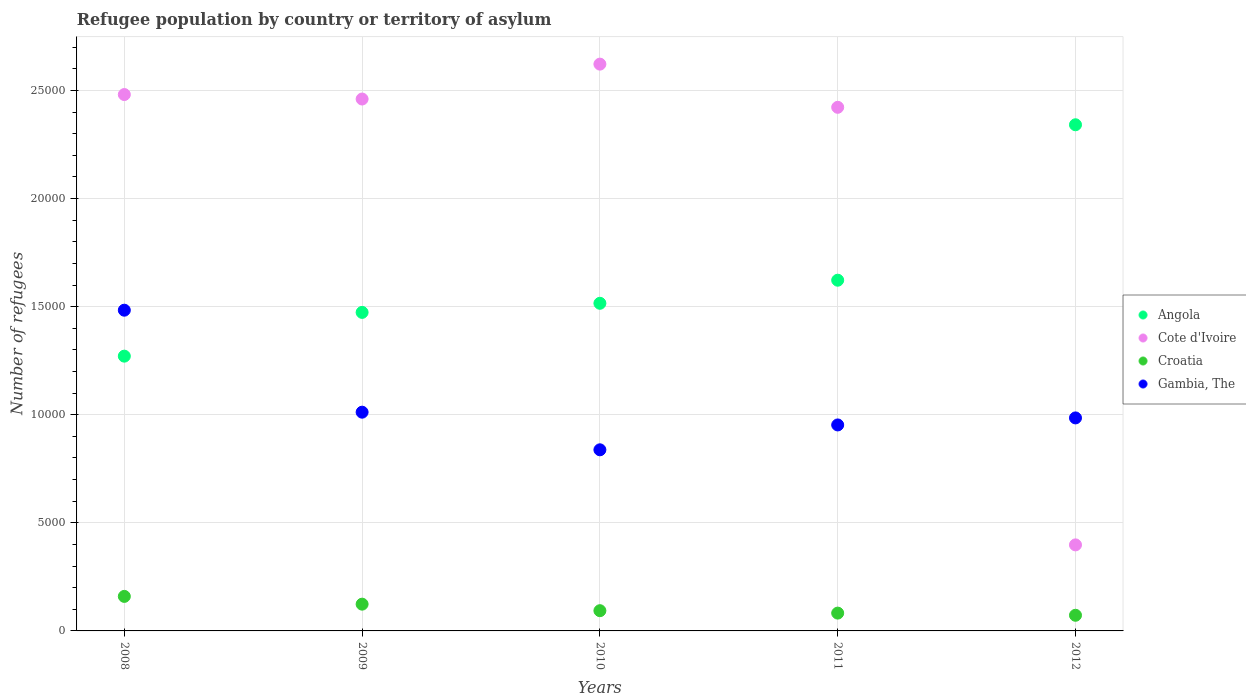What is the number of refugees in Cote d'Ivoire in 2011?
Offer a very short reply. 2.42e+04. Across all years, what is the maximum number of refugees in Angola?
Give a very brief answer. 2.34e+04. Across all years, what is the minimum number of refugees in Angola?
Offer a terse response. 1.27e+04. In which year was the number of refugees in Cote d'Ivoire maximum?
Your answer should be compact. 2010. In which year was the number of refugees in Gambia, The minimum?
Ensure brevity in your answer.  2010. What is the total number of refugees in Croatia in the graph?
Make the answer very short. 5319. What is the difference between the number of refugees in Angola in 2008 and that in 2012?
Your answer should be very brief. -1.07e+04. What is the difference between the number of refugees in Angola in 2011 and the number of refugees in Cote d'Ivoire in 2012?
Keep it short and to the point. 1.22e+04. What is the average number of refugees in Angola per year?
Your response must be concise. 1.64e+04. In the year 2012, what is the difference between the number of refugees in Croatia and number of refugees in Angola?
Keep it short and to the point. -2.27e+04. What is the ratio of the number of refugees in Cote d'Ivoire in 2010 to that in 2012?
Make the answer very short. 6.59. What is the difference between the highest and the second highest number of refugees in Gambia, The?
Your answer should be compact. 4718. What is the difference between the highest and the lowest number of refugees in Cote d'Ivoire?
Make the answer very short. 2.22e+04. Is the sum of the number of refugees in Angola in 2009 and 2010 greater than the maximum number of refugees in Croatia across all years?
Ensure brevity in your answer.  Yes. Is it the case that in every year, the sum of the number of refugees in Angola and number of refugees in Gambia, The  is greater than the sum of number of refugees in Cote d'Ivoire and number of refugees in Croatia?
Give a very brief answer. No. How many dotlines are there?
Offer a terse response. 4. What is the difference between two consecutive major ticks on the Y-axis?
Your response must be concise. 5000. Are the values on the major ticks of Y-axis written in scientific E-notation?
Provide a short and direct response. No. Does the graph contain grids?
Make the answer very short. Yes. How many legend labels are there?
Ensure brevity in your answer.  4. How are the legend labels stacked?
Your answer should be very brief. Vertical. What is the title of the graph?
Ensure brevity in your answer.  Refugee population by country or territory of asylum. What is the label or title of the Y-axis?
Make the answer very short. Number of refugees. What is the Number of refugees of Angola in 2008?
Your answer should be very brief. 1.27e+04. What is the Number of refugees in Cote d'Ivoire in 2008?
Give a very brief answer. 2.48e+04. What is the Number of refugees of Croatia in 2008?
Provide a short and direct response. 1597. What is the Number of refugees of Gambia, The in 2008?
Ensure brevity in your answer.  1.48e+04. What is the Number of refugees in Angola in 2009?
Provide a short and direct response. 1.47e+04. What is the Number of refugees of Cote d'Ivoire in 2009?
Provide a short and direct response. 2.46e+04. What is the Number of refugees in Croatia in 2009?
Your answer should be compact. 1238. What is the Number of refugees in Gambia, The in 2009?
Keep it short and to the point. 1.01e+04. What is the Number of refugees of Angola in 2010?
Keep it short and to the point. 1.52e+04. What is the Number of refugees of Cote d'Ivoire in 2010?
Offer a terse response. 2.62e+04. What is the Number of refugees in Croatia in 2010?
Ensure brevity in your answer.  936. What is the Number of refugees of Gambia, The in 2010?
Offer a terse response. 8378. What is the Number of refugees in Angola in 2011?
Give a very brief answer. 1.62e+04. What is the Number of refugees of Cote d'Ivoire in 2011?
Your response must be concise. 2.42e+04. What is the Number of refugees of Croatia in 2011?
Ensure brevity in your answer.  824. What is the Number of refugees in Gambia, The in 2011?
Ensure brevity in your answer.  9528. What is the Number of refugees in Angola in 2012?
Provide a short and direct response. 2.34e+04. What is the Number of refugees of Cote d'Ivoire in 2012?
Provide a short and direct response. 3980. What is the Number of refugees of Croatia in 2012?
Ensure brevity in your answer.  724. What is the Number of refugees of Gambia, The in 2012?
Provide a short and direct response. 9853. Across all years, what is the maximum Number of refugees of Angola?
Give a very brief answer. 2.34e+04. Across all years, what is the maximum Number of refugees of Cote d'Ivoire?
Provide a succinct answer. 2.62e+04. Across all years, what is the maximum Number of refugees in Croatia?
Provide a short and direct response. 1597. Across all years, what is the maximum Number of refugees in Gambia, The?
Provide a succinct answer. 1.48e+04. Across all years, what is the minimum Number of refugees in Angola?
Make the answer very short. 1.27e+04. Across all years, what is the minimum Number of refugees of Cote d'Ivoire?
Ensure brevity in your answer.  3980. Across all years, what is the minimum Number of refugees in Croatia?
Give a very brief answer. 724. Across all years, what is the minimum Number of refugees in Gambia, The?
Keep it short and to the point. 8378. What is the total Number of refugees in Angola in the graph?
Ensure brevity in your answer.  8.22e+04. What is the total Number of refugees of Cote d'Ivoire in the graph?
Offer a very short reply. 1.04e+05. What is the total Number of refugees in Croatia in the graph?
Keep it short and to the point. 5319. What is the total Number of refugees of Gambia, The in the graph?
Make the answer very short. 5.27e+04. What is the difference between the Number of refugees in Angola in 2008 and that in 2009?
Your answer should be very brief. -2024. What is the difference between the Number of refugees in Cote d'Ivoire in 2008 and that in 2009?
Provide a short and direct response. 207. What is the difference between the Number of refugees in Croatia in 2008 and that in 2009?
Your answer should be compact. 359. What is the difference between the Number of refugees of Gambia, The in 2008 and that in 2009?
Provide a short and direct response. 4718. What is the difference between the Number of refugees in Angola in 2008 and that in 2010?
Ensure brevity in your answer.  -2445. What is the difference between the Number of refugees of Cote d'Ivoire in 2008 and that in 2010?
Give a very brief answer. -1407. What is the difference between the Number of refugees of Croatia in 2008 and that in 2010?
Keep it short and to the point. 661. What is the difference between the Number of refugees in Gambia, The in 2008 and that in 2010?
Keep it short and to the point. 6458. What is the difference between the Number of refugees in Angola in 2008 and that in 2011?
Provide a short and direct response. -3513. What is the difference between the Number of refugees in Cote d'Ivoire in 2008 and that in 2011?
Offer a terse response. 590. What is the difference between the Number of refugees of Croatia in 2008 and that in 2011?
Make the answer very short. 773. What is the difference between the Number of refugees of Gambia, The in 2008 and that in 2011?
Offer a terse response. 5308. What is the difference between the Number of refugees in Angola in 2008 and that in 2012?
Keep it short and to the point. -1.07e+04. What is the difference between the Number of refugees in Cote d'Ivoire in 2008 and that in 2012?
Ensure brevity in your answer.  2.08e+04. What is the difference between the Number of refugees of Croatia in 2008 and that in 2012?
Your response must be concise. 873. What is the difference between the Number of refugees in Gambia, The in 2008 and that in 2012?
Your answer should be compact. 4983. What is the difference between the Number of refugees in Angola in 2009 and that in 2010?
Offer a very short reply. -421. What is the difference between the Number of refugees in Cote d'Ivoire in 2009 and that in 2010?
Make the answer very short. -1614. What is the difference between the Number of refugees in Croatia in 2009 and that in 2010?
Your answer should be compact. 302. What is the difference between the Number of refugees of Gambia, The in 2009 and that in 2010?
Give a very brief answer. 1740. What is the difference between the Number of refugees in Angola in 2009 and that in 2011?
Keep it short and to the point. -1489. What is the difference between the Number of refugees of Cote d'Ivoire in 2009 and that in 2011?
Make the answer very short. 383. What is the difference between the Number of refugees in Croatia in 2009 and that in 2011?
Provide a succinct answer. 414. What is the difference between the Number of refugees in Gambia, The in 2009 and that in 2011?
Your response must be concise. 590. What is the difference between the Number of refugees in Angola in 2009 and that in 2012?
Your response must be concise. -8679. What is the difference between the Number of refugees of Cote d'Ivoire in 2009 and that in 2012?
Your answer should be compact. 2.06e+04. What is the difference between the Number of refugees in Croatia in 2009 and that in 2012?
Provide a short and direct response. 514. What is the difference between the Number of refugees of Gambia, The in 2009 and that in 2012?
Your answer should be very brief. 265. What is the difference between the Number of refugees in Angola in 2010 and that in 2011?
Your answer should be compact. -1068. What is the difference between the Number of refugees in Cote d'Ivoire in 2010 and that in 2011?
Provide a succinct answer. 1997. What is the difference between the Number of refugees in Croatia in 2010 and that in 2011?
Provide a succinct answer. 112. What is the difference between the Number of refugees of Gambia, The in 2010 and that in 2011?
Your answer should be very brief. -1150. What is the difference between the Number of refugees of Angola in 2010 and that in 2012?
Provide a short and direct response. -8258. What is the difference between the Number of refugees of Cote d'Ivoire in 2010 and that in 2012?
Offer a very short reply. 2.22e+04. What is the difference between the Number of refugees in Croatia in 2010 and that in 2012?
Your answer should be compact. 212. What is the difference between the Number of refugees in Gambia, The in 2010 and that in 2012?
Give a very brief answer. -1475. What is the difference between the Number of refugees in Angola in 2011 and that in 2012?
Provide a succinct answer. -7190. What is the difference between the Number of refugees in Cote d'Ivoire in 2011 and that in 2012?
Provide a succinct answer. 2.02e+04. What is the difference between the Number of refugees in Croatia in 2011 and that in 2012?
Give a very brief answer. 100. What is the difference between the Number of refugees of Gambia, The in 2011 and that in 2012?
Offer a terse response. -325. What is the difference between the Number of refugees of Angola in 2008 and the Number of refugees of Cote d'Ivoire in 2009?
Provide a short and direct response. -1.19e+04. What is the difference between the Number of refugees in Angola in 2008 and the Number of refugees in Croatia in 2009?
Your answer should be compact. 1.15e+04. What is the difference between the Number of refugees in Angola in 2008 and the Number of refugees in Gambia, The in 2009?
Offer a terse response. 2592. What is the difference between the Number of refugees in Cote d'Ivoire in 2008 and the Number of refugees in Croatia in 2009?
Make the answer very short. 2.36e+04. What is the difference between the Number of refugees in Cote d'Ivoire in 2008 and the Number of refugees in Gambia, The in 2009?
Make the answer very short. 1.47e+04. What is the difference between the Number of refugees in Croatia in 2008 and the Number of refugees in Gambia, The in 2009?
Ensure brevity in your answer.  -8521. What is the difference between the Number of refugees of Angola in 2008 and the Number of refugees of Cote d'Ivoire in 2010?
Your answer should be compact. -1.35e+04. What is the difference between the Number of refugees in Angola in 2008 and the Number of refugees in Croatia in 2010?
Ensure brevity in your answer.  1.18e+04. What is the difference between the Number of refugees in Angola in 2008 and the Number of refugees in Gambia, The in 2010?
Ensure brevity in your answer.  4332. What is the difference between the Number of refugees in Cote d'Ivoire in 2008 and the Number of refugees in Croatia in 2010?
Offer a very short reply. 2.39e+04. What is the difference between the Number of refugees of Cote d'Ivoire in 2008 and the Number of refugees of Gambia, The in 2010?
Offer a very short reply. 1.64e+04. What is the difference between the Number of refugees of Croatia in 2008 and the Number of refugees of Gambia, The in 2010?
Offer a very short reply. -6781. What is the difference between the Number of refugees in Angola in 2008 and the Number of refugees in Cote d'Ivoire in 2011?
Ensure brevity in your answer.  -1.15e+04. What is the difference between the Number of refugees in Angola in 2008 and the Number of refugees in Croatia in 2011?
Provide a short and direct response. 1.19e+04. What is the difference between the Number of refugees in Angola in 2008 and the Number of refugees in Gambia, The in 2011?
Keep it short and to the point. 3182. What is the difference between the Number of refugees in Cote d'Ivoire in 2008 and the Number of refugees in Croatia in 2011?
Your response must be concise. 2.40e+04. What is the difference between the Number of refugees of Cote d'Ivoire in 2008 and the Number of refugees of Gambia, The in 2011?
Your response must be concise. 1.53e+04. What is the difference between the Number of refugees in Croatia in 2008 and the Number of refugees in Gambia, The in 2011?
Make the answer very short. -7931. What is the difference between the Number of refugees of Angola in 2008 and the Number of refugees of Cote d'Ivoire in 2012?
Offer a very short reply. 8730. What is the difference between the Number of refugees in Angola in 2008 and the Number of refugees in Croatia in 2012?
Offer a very short reply. 1.20e+04. What is the difference between the Number of refugees of Angola in 2008 and the Number of refugees of Gambia, The in 2012?
Your answer should be very brief. 2857. What is the difference between the Number of refugees of Cote d'Ivoire in 2008 and the Number of refugees of Croatia in 2012?
Make the answer very short. 2.41e+04. What is the difference between the Number of refugees in Cote d'Ivoire in 2008 and the Number of refugees in Gambia, The in 2012?
Offer a terse response. 1.50e+04. What is the difference between the Number of refugees in Croatia in 2008 and the Number of refugees in Gambia, The in 2012?
Your answer should be very brief. -8256. What is the difference between the Number of refugees in Angola in 2009 and the Number of refugees in Cote d'Ivoire in 2010?
Your answer should be very brief. -1.15e+04. What is the difference between the Number of refugees in Angola in 2009 and the Number of refugees in Croatia in 2010?
Offer a very short reply. 1.38e+04. What is the difference between the Number of refugees in Angola in 2009 and the Number of refugees in Gambia, The in 2010?
Keep it short and to the point. 6356. What is the difference between the Number of refugees of Cote d'Ivoire in 2009 and the Number of refugees of Croatia in 2010?
Ensure brevity in your answer.  2.37e+04. What is the difference between the Number of refugees of Cote d'Ivoire in 2009 and the Number of refugees of Gambia, The in 2010?
Provide a short and direct response. 1.62e+04. What is the difference between the Number of refugees of Croatia in 2009 and the Number of refugees of Gambia, The in 2010?
Provide a succinct answer. -7140. What is the difference between the Number of refugees of Angola in 2009 and the Number of refugees of Cote d'Ivoire in 2011?
Provide a succinct answer. -9487. What is the difference between the Number of refugees in Angola in 2009 and the Number of refugees in Croatia in 2011?
Your answer should be very brief. 1.39e+04. What is the difference between the Number of refugees of Angola in 2009 and the Number of refugees of Gambia, The in 2011?
Offer a terse response. 5206. What is the difference between the Number of refugees in Cote d'Ivoire in 2009 and the Number of refugees in Croatia in 2011?
Your answer should be compact. 2.38e+04. What is the difference between the Number of refugees in Cote d'Ivoire in 2009 and the Number of refugees in Gambia, The in 2011?
Give a very brief answer. 1.51e+04. What is the difference between the Number of refugees in Croatia in 2009 and the Number of refugees in Gambia, The in 2011?
Your answer should be very brief. -8290. What is the difference between the Number of refugees in Angola in 2009 and the Number of refugees in Cote d'Ivoire in 2012?
Provide a succinct answer. 1.08e+04. What is the difference between the Number of refugees in Angola in 2009 and the Number of refugees in Croatia in 2012?
Provide a short and direct response. 1.40e+04. What is the difference between the Number of refugees of Angola in 2009 and the Number of refugees of Gambia, The in 2012?
Your answer should be compact. 4881. What is the difference between the Number of refugees in Cote d'Ivoire in 2009 and the Number of refugees in Croatia in 2012?
Offer a terse response. 2.39e+04. What is the difference between the Number of refugees of Cote d'Ivoire in 2009 and the Number of refugees of Gambia, The in 2012?
Offer a very short reply. 1.48e+04. What is the difference between the Number of refugees in Croatia in 2009 and the Number of refugees in Gambia, The in 2012?
Provide a short and direct response. -8615. What is the difference between the Number of refugees of Angola in 2010 and the Number of refugees of Cote d'Ivoire in 2011?
Give a very brief answer. -9066. What is the difference between the Number of refugees in Angola in 2010 and the Number of refugees in Croatia in 2011?
Offer a very short reply. 1.43e+04. What is the difference between the Number of refugees of Angola in 2010 and the Number of refugees of Gambia, The in 2011?
Offer a very short reply. 5627. What is the difference between the Number of refugees in Cote d'Ivoire in 2010 and the Number of refugees in Croatia in 2011?
Provide a succinct answer. 2.54e+04. What is the difference between the Number of refugees of Cote d'Ivoire in 2010 and the Number of refugees of Gambia, The in 2011?
Ensure brevity in your answer.  1.67e+04. What is the difference between the Number of refugees of Croatia in 2010 and the Number of refugees of Gambia, The in 2011?
Ensure brevity in your answer.  -8592. What is the difference between the Number of refugees of Angola in 2010 and the Number of refugees of Cote d'Ivoire in 2012?
Your answer should be compact. 1.12e+04. What is the difference between the Number of refugees in Angola in 2010 and the Number of refugees in Croatia in 2012?
Provide a short and direct response. 1.44e+04. What is the difference between the Number of refugees in Angola in 2010 and the Number of refugees in Gambia, The in 2012?
Offer a very short reply. 5302. What is the difference between the Number of refugees in Cote d'Ivoire in 2010 and the Number of refugees in Croatia in 2012?
Your response must be concise. 2.55e+04. What is the difference between the Number of refugees of Cote d'Ivoire in 2010 and the Number of refugees of Gambia, The in 2012?
Provide a short and direct response. 1.64e+04. What is the difference between the Number of refugees of Croatia in 2010 and the Number of refugees of Gambia, The in 2012?
Ensure brevity in your answer.  -8917. What is the difference between the Number of refugees of Angola in 2011 and the Number of refugees of Cote d'Ivoire in 2012?
Provide a succinct answer. 1.22e+04. What is the difference between the Number of refugees in Angola in 2011 and the Number of refugees in Croatia in 2012?
Offer a very short reply. 1.55e+04. What is the difference between the Number of refugees in Angola in 2011 and the Number of refugees in Gambia, The in 2012?
Make the answer very short. 6370. What is the difference between the Number of refugees of Cote d'Ivoire in 2011 and the Number of refugees of Croatia in 2012?
Make the answer very short. 2.35e+04. What is the difference between the Number of refugees in Cote d'Ivoire in 2011 and the Number of refugees in Gambia, The in 2012?
Make the answer very short. 1.44e+04. What is the difference between the Number of refugees in Croatia in 2011 and the Number of refugees in Gambia, The in 2012?
Offer a terse response. -9029. What is the average Number of refugees of Angola per year?
Provide a short and direct response. 1.64e+04. What is the average Number of refugees of Cote d'Ivoire per year?
Keep it short and to the point. 2.08e+04. What is the average Number of refugees of Croatia per year?
Your answer should be very brief. 1063.8. What is the average Number of refugees in Gambia, The per year?
Provide a succinct answer. 1.05e+04. In the year 2008, what is the difference between the Number of refugees of Angola and Number of refugees of Cote d'Ivoire?
Your answer should be compact. -1.21e+04. In the year 2008, what is the difference between the Number of refugees of Angola and Number of refugees of Croatia?
Your response must be concise. 1.11e+04. In the year 2008, what is the difference between the Number of refugees in Angola and Number of refugees in Gambia, The?
Your answer should be very brief. -2126. In the year 2008, what is the difference between the Number of refugees in Cote d'Ivoire and Number of refugees in Croatia?
Give a very brief answer. 2.32e+04. In the year 2008, what is the difference between the Number of refugees of Cote d'Ivoire and Number of refugees of Gambia, The?
Your response must be concise. 9975. In the year 2008, what is the difference between the Number of refugees in Croatia and Number of refugees in Gambia, The?
Offer a terse response. -1.32e+04. In the year 2009, what is the difference between the Number of refugees in Angola and Number of refugees in Cote d'Ivoire?
Make the answer very short. -9870. In the year 2009, what is the difference between the Number of refugees in Angola and Number of refugees in Croatia?
Provide a succinct answer. 1.35e+04. In the year 2009, what is the difference between the Number of refugees in Angola and Number of refugees in Gambia, The?
Keep it short and to the point. 4616. In the year 2009, what is the difference between the Number of refugees of Cote d'Ivoire and Number of refugees of Croatia?
Ensure brevity in your answer.  2.34e+04. In the year 2009, what is the difference between the Number of refugees in Cote d'Ivoire and Number of refugees in Gambia, The?
Your response must be concise. 1.45e+04. In the year 2009, what is the difference between the Number of refugees in Croatia and Number of refugees in Gambia, The?
Make the answer very short. -8880. In the year 2010, what is the difference between the Number of refugees in Angola and Number of refugees in Cote d'Ivoire?
Your answer should be compact. -1.11e+04. In the year 2010, what is the difference between the Number of refugees of Angola and Number of refugees of Croatia?
Your answer should be compact. 1.42e+04. In the year 2010, what is the difference between the Number of refugees in Angola and Number of refugees in Gambia, The?
Your response must be concise. 6777. In the year 2010, what is the difference between the Number of refugees of Cote d'Ivoire and Number of refugees of Croatia?
Your answer should be very brief. 2.53e+04. In the year 2010, what is the difference between the Number of refugees of Cote d'Ivoire and Number of refugees of Gambia, The?
Ensure brevity in your answer.  1.78e+04. In the year 2010, what is the difference between the Number of refugees in Croatia and Number of refugees in Gambia, The?
Offer a very short reply. -7442. In the year 2011, what is the difference between the Number of refugees in Angola and Number of refugees in Cote d'Ivoire?
Keep it short and to the point. -7998. In the year 2011, what is the difference between the Number of refugees of Angola and Number of refugees of Croatia?
Your answer should be very brief. 1.54e+04. In the year 2011, what is the difference between the Number of refugees in Angola and Number of refugees in Gambia, The?
Your response must be concise. 6695. In the year 2011, what is the difference between the Number of refugees of Cote d'Ivoire and Number of refugees of Croatia?
Give a very brief answer. 2.34e+04. In the year 2011, what is the difference between the Number of refugees of Cote d'Ivoire and Number of refugees of Gambia, The?
Give a very brief answer. 1.47e+04. In the year 2011, what is the difference between the Number of refugees of Croatia and Number of refugees of Gambia, The?
Give a very brief answer. -8704. In the year 2012, what is the difference between the Number of refugees of Angola and Number of refugees of Cote d'Ivoire?
Keep it short and to the point. 1.94e+04. In the year 2012, what is the difference between the Number of refugees of Angola and Number of refugees of Croatia?
Make the answer very short. 2.27e+04. In the year 2012, what is the difference between the Number of refugees of Angola and Number of refugees of Gambia, The?
Your response must be concise. 1.36e+04. In the year 2012, what is the difference between the Number of refugees of Cote d'Ivoire and Number of refugees of Croatia?
Your answer should be very brief. 3256. In the year 2012, what is the difference between the Number of refugees of Cote d'Ivoire and Number of refugees of Gambia, The?
Offer a very short reply. -5873. In the year 2012, what is the difference between the Number of refugees of Croatia and Number of refugees of Gambia, The?
Make the answer very short. -9129. What is the ratio of the Number of refugees of Angola in 2008 to that in 2009?
Your response must be concise. 0.86. What is the ratio of the Number of refugees of Cote d'Ivoire in 2008 to that in 2009?
Your response must be concise. 1.01. What is the ratio of the Number of refugees in Croatia in 2008 to that in 2009?
Give a very brief answer. 1.29. What is the ratio of the Number of refugees in Gambia, The in 2008 to that in 2009?
Give a very brief answer. 1.47. What is the ratio of the Number of refugees of Angola in 2008 to that in 2010?
Make the answer very short. 0.84. What is the ratio of the Number of refugees in Cote d'Ivoire in 2008 to that in 2010?
Offer a very short reply. 0.95. What is the ratio of the Number of refugees in Croatia in 2008 to that in 2010?
Make the answer very short. 1.71. What is the ratio of the Number of refugees in Gambia, The in 2008 to that in 2010?
Give a very brief answer. 1.77. What is the ratio of the Number of refugees in Angola in 2008 to that in 2011?
Your answer should be compact. 0.78. What is the ratio of the Number of refugees in Cote d'Ivoire in 2008 to that in 2011?
Offer a terse response. 1.02. What is the ratio of the Number of refugees in Croatia in 2008 to that in 2011?
Provide a short and direct response. 1.94. What is the ratio of the Number of refugees of Gambia, The in 2008 to that in 2011?
Make the answer very short. 1.56. What is the ratio of the Number of refugees of Angola in 2008 to that in 2012?
Make the answer very short. 0.54. What is the ratio of the Number of refugees of Cote d'Ivoire in 2008 to that in 2012?
Offer a very short reply. 6.23. What is the ratio of the Number of refugees of Croatia in 2008 to that in 2012?
Your answer should be compact. 2.21. What is the ratio of the Number of refugees in Gambia, The in 2008 to that in 2012?
Your response must be concise. 1.51. What is the ratio of the Number of refugees of Angola in 2009 to that in 2010?
Your answer should be compact. 0.97. What is the ratio of the Number of refugees in Cote d'Ivoire in 2009 to that in 2010?
Provide a succinct answer. 0.94. What is the ratio of the Number of refugees of Croatia in 2009 to that in 2010?
Your answer should be very brief. 1.32. What is the ratio of the Number of refugees of Gambia, The in 2009 to that in 2010?
Offer a very short reply. 1.21. What is the ratio of the Number of refugees in Angola in 2009 to that in 2011?
Your answer should be very brief. 0.91. What is the ratio of the Number of refugees of Cote d'Ivoire in 2009 to that in 2011?
Your answer should be compact. 1.02. What is the ratio of the Number of refugees in Croatia in 2009 to that in 2011?
Provide a short and direct response. 1.5. What is the ratio of the Number of refugees of Gambia, The in 2009 to that in 2011?
Your response must be concise. 1.06. What is the ratio of the Number of refugees in Angola in 2009 to that in 2012?
Keep it short and to the point. 0.63. What is the ratio of the Number of refugees of Cote d'Ivoire in 2009 to that in 2012?
Offer a very short reply. 6.18. What is the ratio of the Number of refugees of Croatia in 2009 to that in 2012?
Give a very brief answer. 1.71. What is the ratio of the Number of refugees of Gambia, The in 2009 to that in 2012?
Your answer should be compact. 1.03. What is the ratio of the Number of refugees of Angola in 2010 to that in 2011?
Your answer should be very brief. 0.93. What is the ratio of the Number of refugees in Cote d'Ivoire in 2010 to that in 2011?
Keep it short and to the point. 1.08. What is the ratio of the Number of refugees in Croatia in 2010 to that in 2011?
Offer a terse response. 1.14. What is the ratio of the Number of refugees in Gambia, The in 2010 to that in 2011?
Give a very brief answer. 0.88. What is the ratio of the Number of refugees of Angola in 2010 to that in 2012?
Provide a short and direct response. 0.65. What is the ratio of the Number of refugees in Cote d'Ivoire in 2010 to that in 2012?
Keep it short and to the point. 6.59. What is the ratio of the Number of refugees of Croatia in 2010 to that in 2012?
Provide a succinct answer. 1.29. What is the ratio of the Number of refugees of Gambia, The in 2010 to that in 2012?
Make the answer very short. 0.85. What is the ratio of the Number of refugees in Angola in 2011 to that in 2012?
Your answer should be very brief. 0.69. What is the ratio of the Number of refugees of Cote d'Ivoire in 2011 to that in 2012?
Give a very brief answer. 6.09. What is the ratio of the Number of refugees of Croatia in 2011 to that in 2012?
Provide a succinct answer. 1.14. What is the ratio of the Number of refugees of Gambia, The in 2011 to that in 2012?
Give a very brief answer. 0.97. What is the difference between the highest and the second highest Number of refugees of Angola?
Your response must be concise. 7190. What is the difference between the highest and the second highest Number of refugees in Cote d'Ivoire?
Make the answer very short. 1407. What is the difference between the highest and the second highest Number of refugees in Croatia?
Your response must be concise. 359. What is the difference between the highest and the second highest Number of refugees in Gambia, The?
Offer a very short reply. 4718. What is the difference between the highest and the lowest Number of refugees of Angola?
Provide a succinct answer. 1.07e+04. What is the difference between the highest and the lowest Number of refugees of Cote d'Ivoire?
Offer a very short reply. 2.22e+04. What is the difference between the highest and the lowest Number of refugees of Croatia?
Your response must be concise. 873. What is the difference between the highest and the lowest Number of refugees in Gambia, The?
Make the answer very short. 6458. 